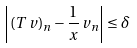<formula> <loc_0><loc_0><loc_500><loc_500>\left | ( T \, v ) _ { n } - \frac { 1 } { x } \, v _ { n } \right | \leq \delta</formula> 